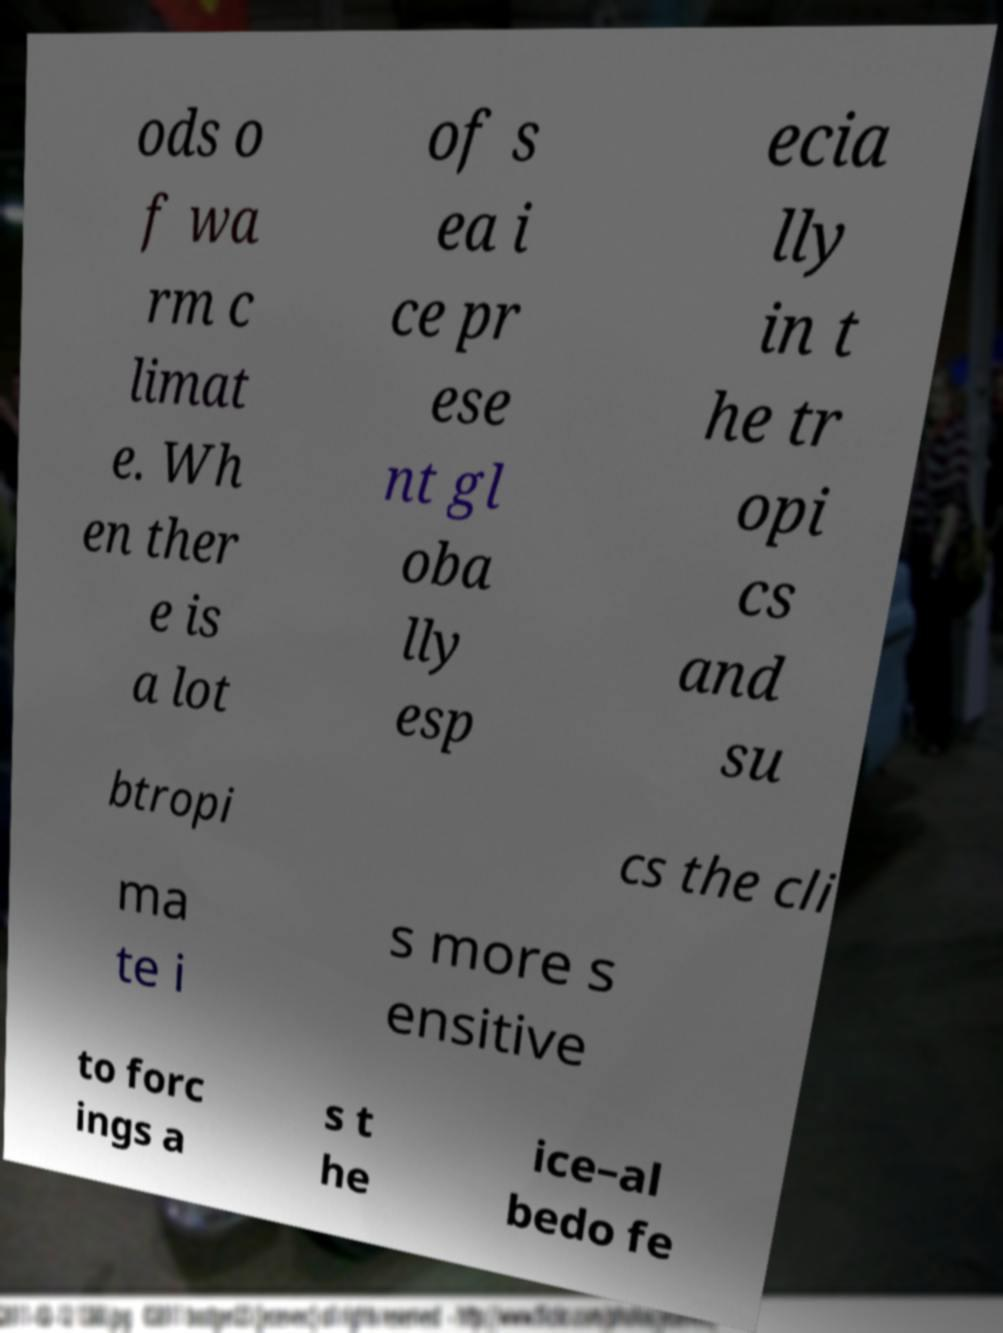Please identify and transcribe the text found in this image. ods o f wa rm c limat e. Wh en ther e is a lot of s ea i ce pr ese nt gl oba lly esp ecia lly in t he tr opi cs and su btropi cs the cli ma te i s more s ensitive to forc ings a s t he ice–al bedo fe 